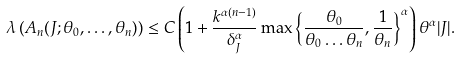Convert formula to latex. <formula><loc_0><loc_0><loc_500><loc_500>\lambda \left ( A _ { n } ( J ; \theta _ { 0 } , \dots , \theta _ { n } ) \right ) \leq C \left ( 1 + \frac { k ^ { \alpha ( n - 1 ) } } { \delta _ { J } ^ { \alpha } } \max \left \{ \frac { \theta _ { 0 } } { \theta _ { 0 } \dots \theta _ { n } } , \frac { 1 } { \theta _ { n } } \right \} ^ { \alpha } \right ) \theta ^ { \alpha } | J | .</formula> 